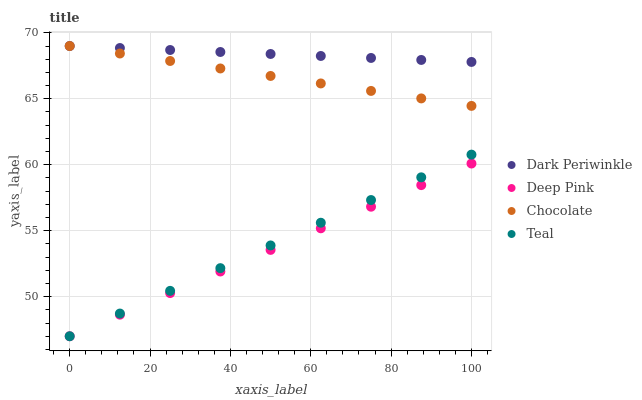Does Deep Pink have the minimum area under the curve?
Answer yes or no. Yes. Does Dark Periwinkle have the maximum area under the curve?
Answer yes or no. Yes. Does Teal have the minimum area under the curve?
Answer yes or no. No. Does Teal have the maximum area under the curve?
Answer yes or no. No. Is Dark Periwinkle the smoothest?
Answer yes or no. Yes. Is Chocolate the roughest?
Answer yes or no. Yes. Is Teal the smoothest?
Answer yes or no. No. Is Teal the roughest?
Answer yes or no. No. Does Deep Pink have the lowest value?
Answer yes or no. Yes. Does Dark Periwinkle have the lowest value?
Answer yes or no. No. Does Chocolate have the highest value?
Answer yes or no. Yes. Does Teal have the highest value?
Answer yes or no. No. Is Deep Pink less than Chocolate?
Answer yes or no. Yes. Is Dark Periwinkle greater than Teal?
Answer yes or no. Yes. Does Deep Pink intersect Teal?
Answer yes or no. Yes. Is Deep Pink less than Teal?
Answer yes or no. No. Is Deep Pink greater than Teal?
Answer yes or no. No. Does Deep Pink intersect Chocolate?
Answer yes or no. No. 